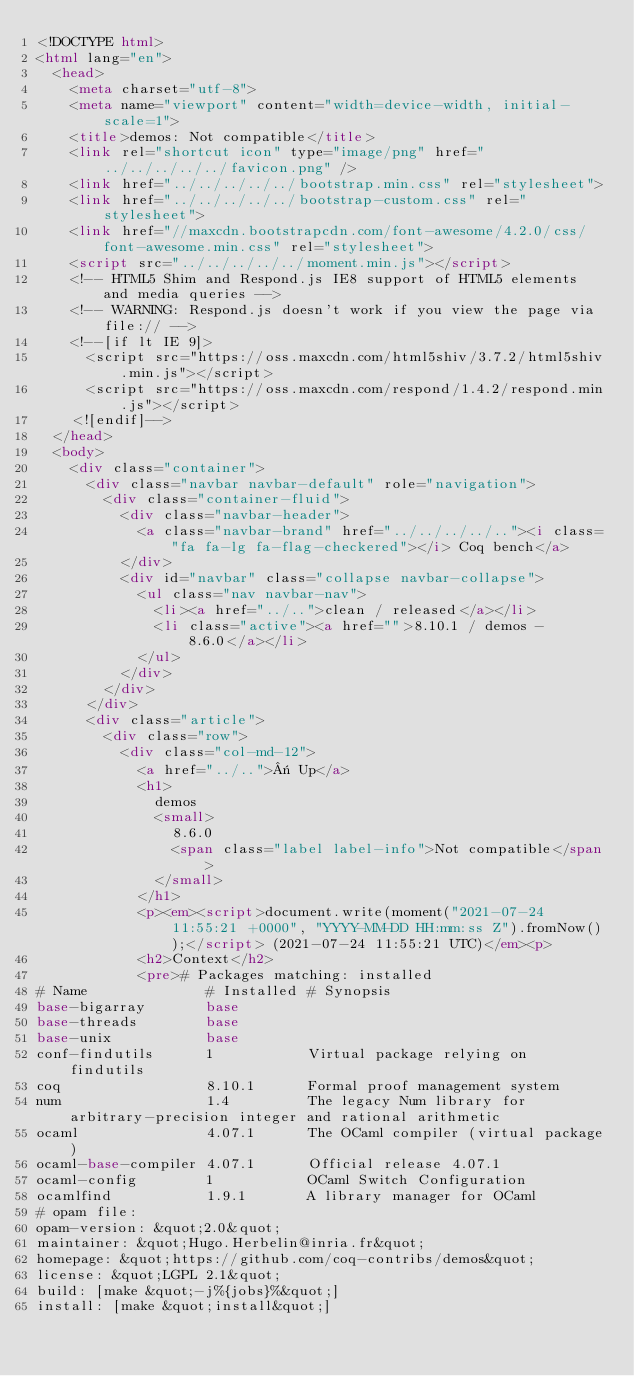Convert code to text. <code><loc_0><loc_0><loc_500><loc_500><_HTML_><!DOCTYPE html>
<html lang="en">
  <head>
    <meta charset="utf-8">
    <meta name="viewport" content="width=device-width, initial-scale=1">
    <title>demos: Not compatible</title>
    <link rel="shortcut icon" type="image/png" href="../../../../../favicon.png" />
    <link href="../../../../../bootstrap.min.css" rel="stylesheet">
    <link href="../../../../../bootstrap-custom.css" rel="stylesheet">
    <link href="//maxcdn.bootstrapcdn.com/font-awesome/4.2.0/css/font-awesome.min.css" rel="stylesheet">
    <script src="../../../../../moment.min.js"></script>
    <!-- HTML5 Shim and Respond.js IE8 support of HTML5 elements and media queries -->
    <!-- WARNING: Respond.js doesn't work if you view the page via file:// -->
    <!--[if lt IE 9]>
      <script src="https://oss.maxcdn.com/html5shiv/3.7.2/html5shiv.min.js"></script>
      <script src="https://oss.maxcdn.com/respond/1.4.2/respond.min.js"></script>
    <![endif]-->
  </head>
  <body>
    <div class="container">
      <div class="navbar navbar-default" role="navigation">
        <div class="container-fluid">
          <div class="navbar-header">
            <a class="navbar-brand" href="../../../../.."><i class="fa fa-lg fa-flag-checkered"></i> Coq bench</a>
          </div>
          <div id="navbar" class="collapse navbar-collapse">
            <ul class="nav navbar-nav">
              <li><a href="../..">clean / released</a></li>
              <li class="active"><a href="">8.10.1 / demos - 8.6.0</a></li>
            </ul>
          </div>
        </div>
      </div>
      <div class="article">
        <div class="row">
          <div class="col-md-12">
            <a href="../..">« Up</a>
            <h1>
              demos
              <small>
                8.6.0
                <span class="label label-info">Not compatible</span>
              </small>
            </h1>
            <p><em><script>document.write(moment("2021-07-24 11:55:21 +0000", "YYYY-MM-DD HH:mm:ss Z").fromNow());</script> (2021-07-24 11:55:21 UTC)</em><p>
            <h2>Context</h2>
            <pre># Packages matching: installed
# Name              # Installed # Synopsis
base-bigarray       base
base-threads        base
base-unix           base
conf-findutils      1           Virtual package relying on findutils
coq                 8.10.1      Formal proof management system
num                 1.4         The legacy Num library for arbitrary-precision integer and rational arithmetic
ocaml               4.07.1      The OCaml compiler (virtual package)
ocaml-base-compiler 4.07.1      Official release 4.07.1
ocaml-config        1           OCaml Switch Configuration
ocamlfind           1.9.1       A library manager for OCaml
# opam file:
opam-version: &quot;2.0&quot;
maintainer: &quot;Hugo.Herbelin@inria.fr&quot;
homepage: &quot;https://github.com/coq-contribs/demos&quot;
license: &quot;LGPL 2.1&quot;
build: [make &quot;-j%{jobs}%&quot;]
install: [make &quot;install&quot;]</code> 